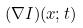<formula> <loc_0><loc_0><loc_500><loc_500>( \nabla I ) ( x ; t )</formula> 